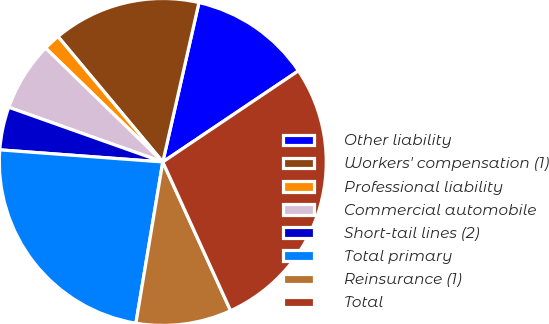Convert chart to OTSL. <chart><loc_0><loc_0><loc_500><loc_500><pie_chart><fcel>Other liability<fcel>Workers' compensation (1)<fcel>Professional liability<fcel>Commercial automobile<fcel>Short-tail lines (2)<fcel>Total primary<fcel>Reinsurance (1)<fcel>Total<nl><fcel>12.03%<fcel>14.63%<fcel>1.65%<fcel>6.84%<fcel>4.25%<fcel>23.55%<fcel>9.44%<fcel>27.61%<nl></chart> 